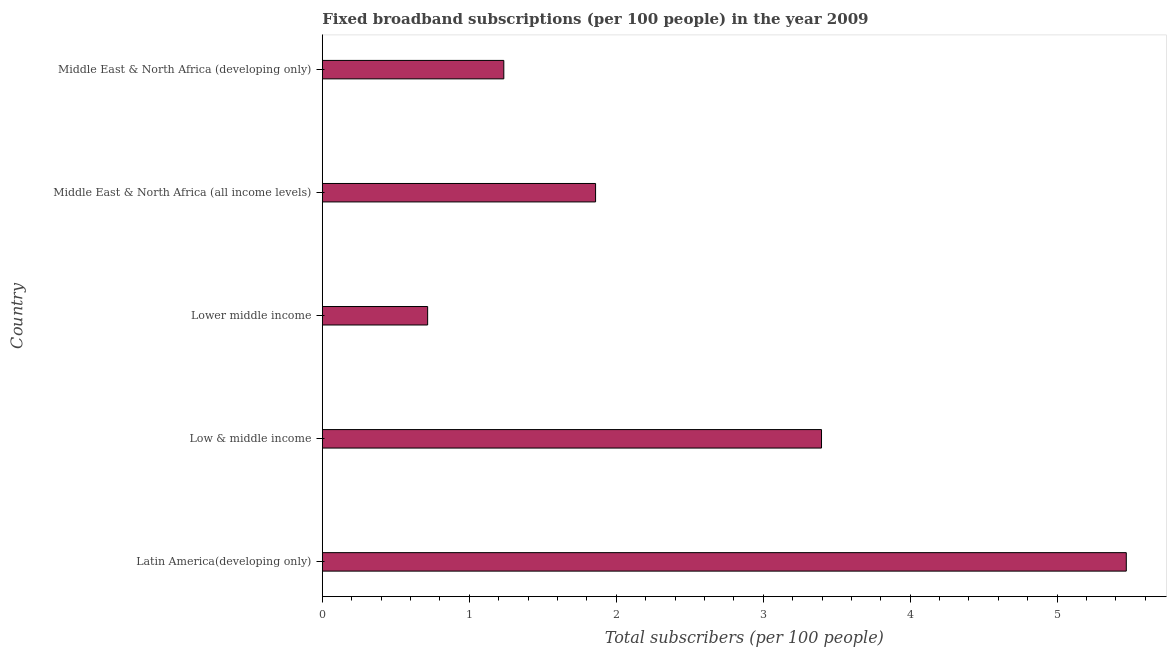Does the graph contain grids?
Offer a very short reply. No. What is the title of the graph?
Give a very brief answer. Fixed broadband subscriptions (per 100 people) in the year 2009. What is the label or title of the X-axis?
Ensure brevity in your answer.  Total subscribers (per 100 people). What is the total number of fixed broadband subscriptions in Latin America(developing only)?
Your answer should be very brief. 5.47. Across all countries, what is the maximum total number of fixed broadband subscriptions?
Make the answer very short. 5.47. Across all countries, what is the minimum total number of fixed broadband subscriptions?
Offer a very short reply. 0.72. In which country was the total number of fixed broadband subscriptions maximum?
Provide a succinct answer. Latin America(developing only). In which country was the total number of fixed broadband subscriptions minimum?
Make the answer very short. Lower middle income. What is the sum of the total number of fixed broadband subscriptions?
Your answer should be compact. 12.68. What is the difference between the total number of fixed broadband subscriptions in Low & middle income and Middle East & North Africa (all income levels)?
Make the answer very short. 1.54. What is the average total number of fixed broadband subscriptions per country?
Offer a terse response. 2.54. What is the median total number of fixed broadband subscriptions?
Offer a very short reply. 1.86. In how many countries, is the total number of fixed broadband subscriptions greater than 2 ?
Your answer should be very brief. 2. What is the ratio of the total number of fixed broadband subscriptions in Latin America(developing only) to that in Lower middle income?
Provide a succinct answer. 7.63. What is the difference between the highest and the second highest total number of fixed broadband subscriptions?
Keep it short and to the point. 2.07. What is the difference between the highest and the lowest total number of fixed broadband subscriptions?
Your answer should be very brief. 4.75. What is the Total subscribers (per 100 people) in Latin America(developing only)?
Make the answer very short. 5.47. What is the Total subscribers (per 100 people) in Low & middle income?
Provide a short and direct response. 3.4. What is the Total subscribers (per 100 people) in Lower middle income?
Keep it short and to the point. 0.72. What is the Total subscribers (per 100 people) of Middle East & North Africa (all income levels)?
Ensure brevity in your answer.  1.86. What is the Total subscribers (per 100 people) in Middle East & North Africa (developing only)?
Your response must be concise. 1.23. What is the difference between the Total subscribers (per 100 people) in Latin America(developing only) and Low & middle income?
Provide a short and direct response. 2.07. What is the difference between the Total subscribers (per 100 people) in Latin America(developing only) and Lower middle income?
Give a very brief answer. 4.75. What is the difference between the Total subscribers (per 100 people) in Latin America(developing only) and Middle East & North Africa (all income levels)?
Your response must be concise. 3.61. What is the difference between the Total subscribers (per 100 people) in Latin America(developing only) and Middle East & North Africa (developing only)?
Ensure brevity in your answer.  4.24. What is the difference between the Total subscribers (per 100 people) in Low & middle income and Lower middle income?
Your response must be concise. 2.68. What is the difference between the Total subscribers (per 100 people) in Low & middle income and Middle East & North Africa (all income levels)?
Make the answer very short. 1.54. What is the difference between the Total subscribers (per 100 people) in Low & middle income and Middle East & North Africa (developing only)?
Ensure brevity in your answer.  2.16. What is the difference between the Total subscribers (per 100 people) in Lower middle income and Middle East & North Africa (all income levels)?
Keep it short and to the point. -1.14. What is the difference between the Total subscribers (per 100 people) in Lower middle income and Middle East & North Africa (developing only)?
Keep it short and to the point. -0.52. What is the difference between the Total subscribers (per 100 people) in Middle East & North Africa (all income levels) and Middle East & North Africa (developing only)?
Your response must be concise. 0.62. What is the ratio of the Total subscribers (per 100 people) in Latin America(developing only) to that in Low & middle income?
Your answer should be compact. 1.61. What is the ratio of the Total subscribers (per 100 people) in Latin America(developing only) to that in Lower middle income?
Offer a very short reply. 7.63. What is the ratio of the Total subscribers (per 100 people) in Latin America(developing only) to that in Middle East & North Africa (all income levels)?
Ensure brevity in your answer.  2.94. What is the ratio of the Total subscribers (per 100 people) in Latin America(developing only) to that in Middle East & North Africa (developing only)?
Make the answer very short. 4.43. What is the ratio of the Total subscribers (per 100 people) in Low & middle income to that in Lower middle income?
Your answer should be compact. 4.74. What is the ratio of the Total subscribers (per 100 people) in Low & middle income to that in Middle East & North Africa (all income levels)?
Provide a short and direct response. 1.83. What is the ratio of the Total subscribers (per 100 people) in Low & middle income to that in Middle East & North Africa (developing only)?
Your response must be concise. 2.75. What is the ratio of the Total subscribers (per 100 people) in Lower middle income to that in Middle East & North Africa (all income levels)?
Offer a very short reply. 0.39. What is the ratio of the Total subscribers (per 100 people) in Lower middle income to that in Middle East & North Africa (developing only)?
Provide a succinct answer. 0.58. What is the ratio of the Total subscribers (per 100 people) in Middle East & North Africa (all income levels) to that in Middle East & North Africa (developing only)?
Your response must be concise. 1.51. 